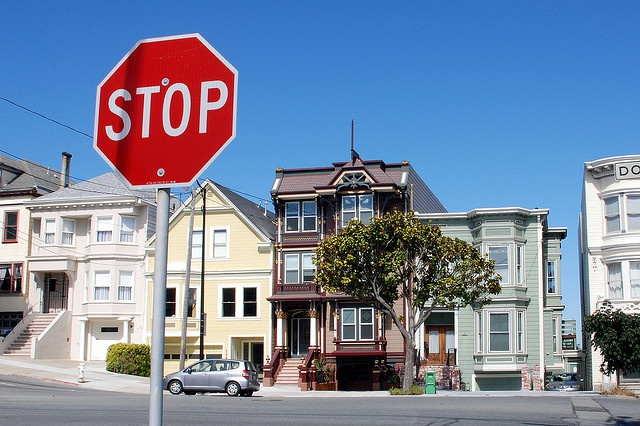Describe the objects in this image and their specific colors. I can see stop sign in blue, brown, lightgray, and maroon tones, car in blue, black, lightgray, darkgray, and gray tones, car in blue, gray, black, and darkgray tones, and fire hydrant in blue, lightgray, and darkgray tones in this image. 